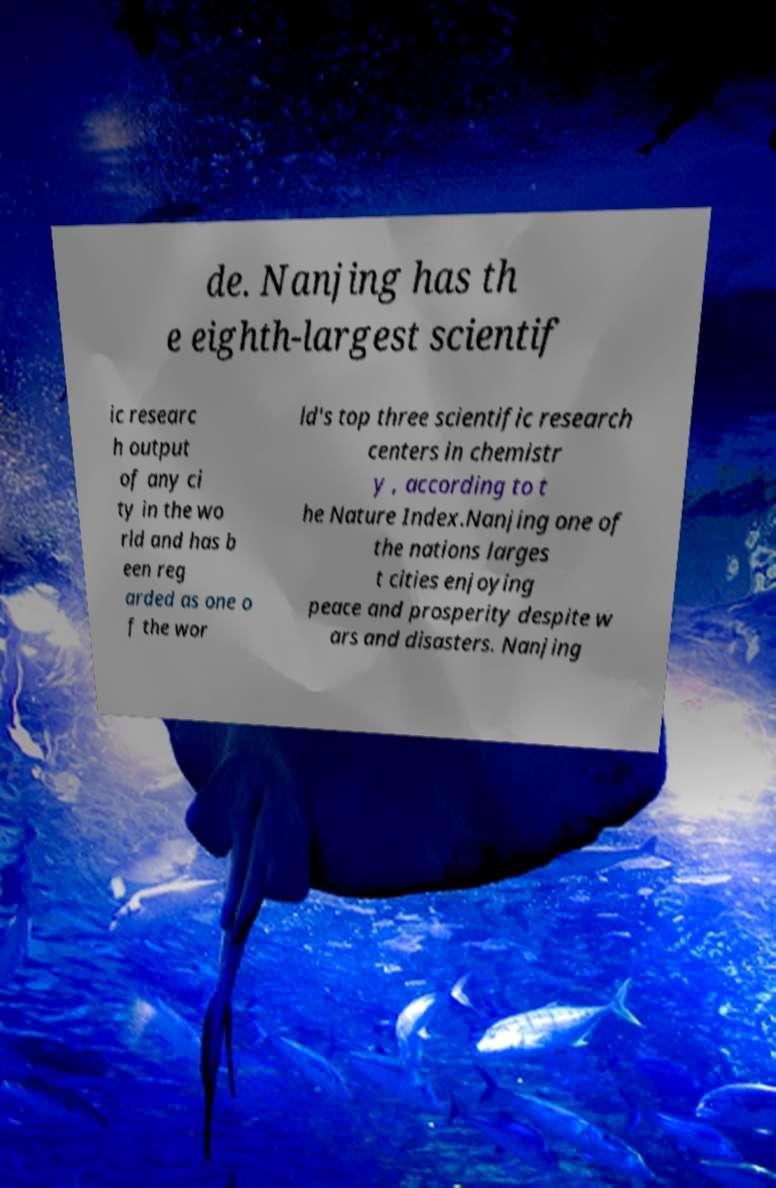Please read and relay the text visible in this image. What does it say? de. Nanjing has th e eighth-largest scientif ic researc h output of any ci ty in the wo rld and has b een reg arded as one o f the wor ld's top three scientific research centers in chemistr y , according to t he Nature Index.Nanjing one of the nations larges t cities enjoying peace and prosperity despite w ars and disasters. Nanjing 